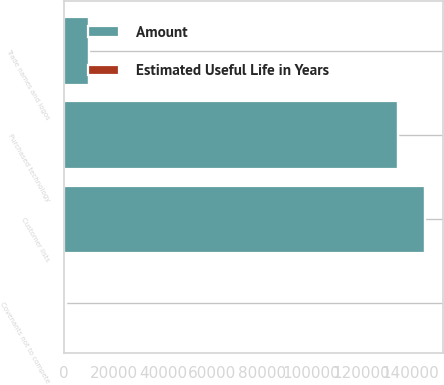Convert chart. <chart><loc_0><loc_0><loc_500><loc_500><stacked_bar_chart><ecel><fcel>Customer lists<fcel>Purchased technology<fcel>Trade names and logos<fcel>Covenants not to compete<nl><fcel>Estimated Useful Life in Years<fcel>5<fcel>3<fcel>5<fcel>3<nl><fcel>Amount<fcel>146000<fcel>134800<fcel>10000<fcel>700<nl></chart> 